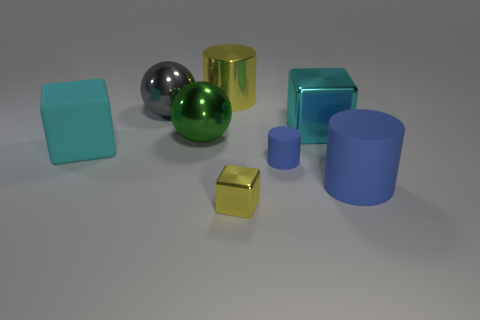Subtract all blue rubber cylinders. How many cylinders are left? 1 Add 1 tiny cylinders. How many objects exist? 9 Subtract all cylinders. How many objects are left? 5 Subtract all tiny yellow objects. Subtract all small green balls. How many objects are left? 7 Add 5 small yellow shiny blocks. How many small yellow shiny blocks are left? 6 Add 5 tiny brown matte cylinders. How many tiny brown matte cylinders exist? 5 Subtract 0 cyan cylinders. How many objects are left? 8 